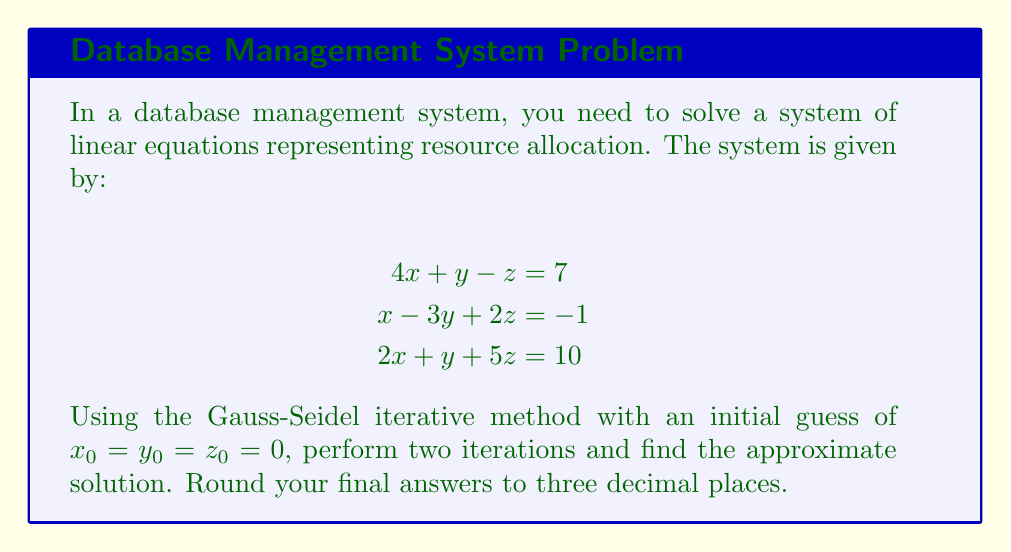Solve this math problem. To solve this system using the Gauss-Seidel method, we'll follow these steps:

1) Rearrange the equations to isolate x, y, and z:

   $$x = \frac{1}{4}(7 - y + z)$$
   $$y = \frac{1}{3}(x + 2z + 1)$$
   $$z = \frac{1}{5}(10 - 2x - y)$$

2) Start with the initial guess: $x_0 = y_0 = z_0 = 0$

3) First iteration:
   
   $x_1 = \frac{1}{4}(7 - 0 + 0) = 1.75$
   
   $y_1 = \frac{1}{3}(1.75 + 2(0) + 1) = 0.917$
   
   $z_1 = \frac{1}{5}(10 - 2(1.75) - 0.917) = 1.113$

4) Second iteration:
   
   $x_2 = \frac{1}{4}(7 - 0.917 + 1.113) = 1.799$
   
   $y_2 = \frac{1}{3}(1.799 + 2(1.113) + 1) = 1.713$
   
   $z_2 = \frac{1}{5}(10 - 2(1.799) - 1.713) = 0.938$

5) Rounding to three decimal places:
   
   $x \approx 1.799$
   $y \approx 1.713$
   $z \approx 0.938$
Answer: $x \approx 1.799$, $y \approx 1.713$, $z \approx 0.938$ 